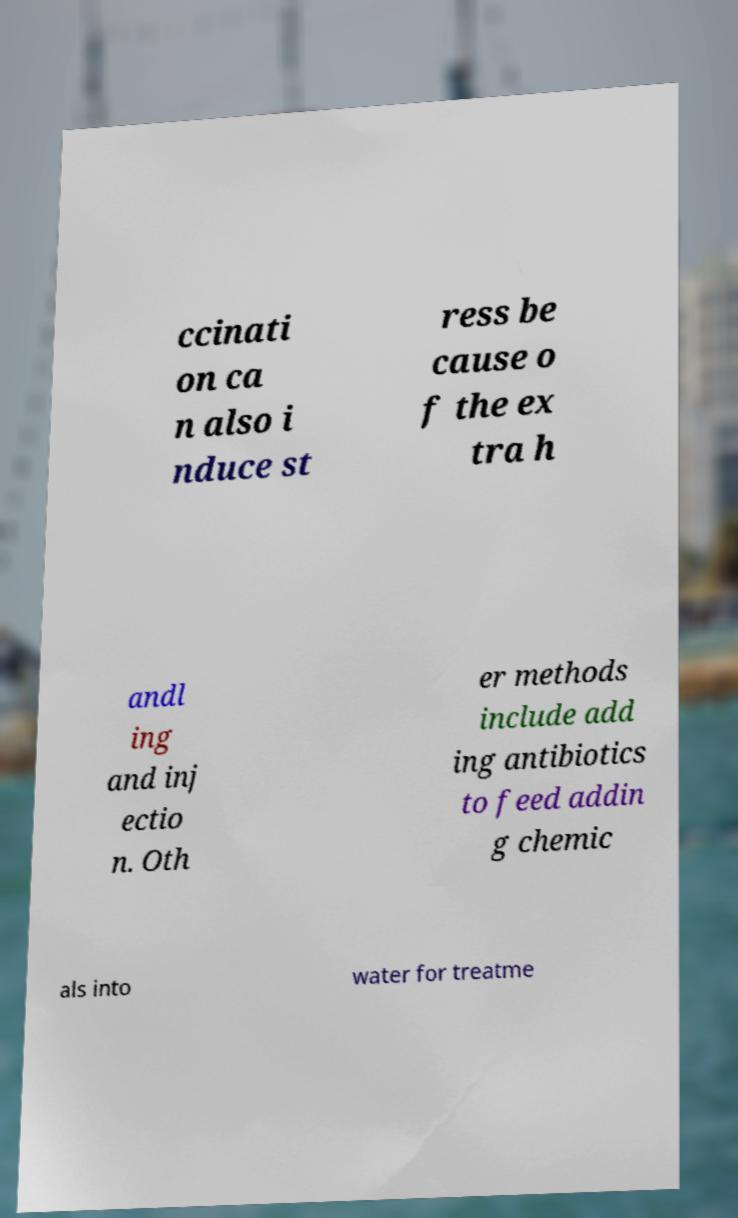Please identify and transcribe the text found in this image. ccinati on ca n also i nduce st ress be cause o f the ex tra h andl ing and inj ectio n. Oth er methods include add ing antibiotics to feed addin g chemic als into water for treatme 